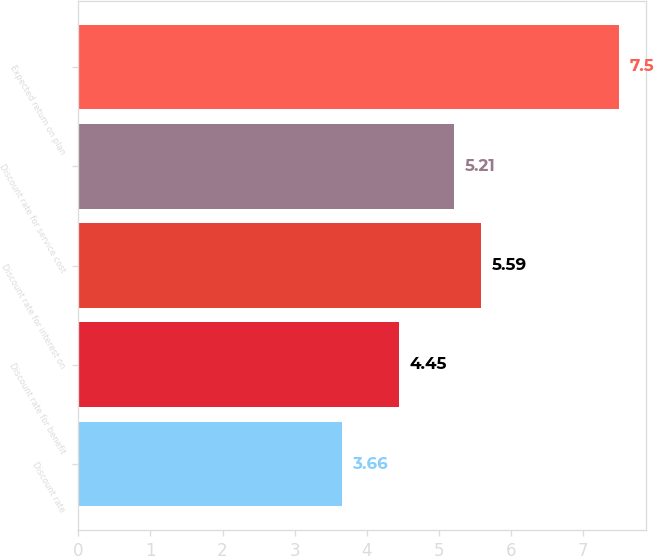<chart> <loc_0><loc_0><loc_500><loc_500><bar_chart><fcel>Discount rate<fcel>Discount rate for benefit<fcel>Discount rate for interest on<fcel>Discount rate for service cost<fcel>Expected return on plan<nl><fcel>3.66<fcel>4.45<fcel>5.59<fcel>5.21<fcel>7.5<nl></chart> 